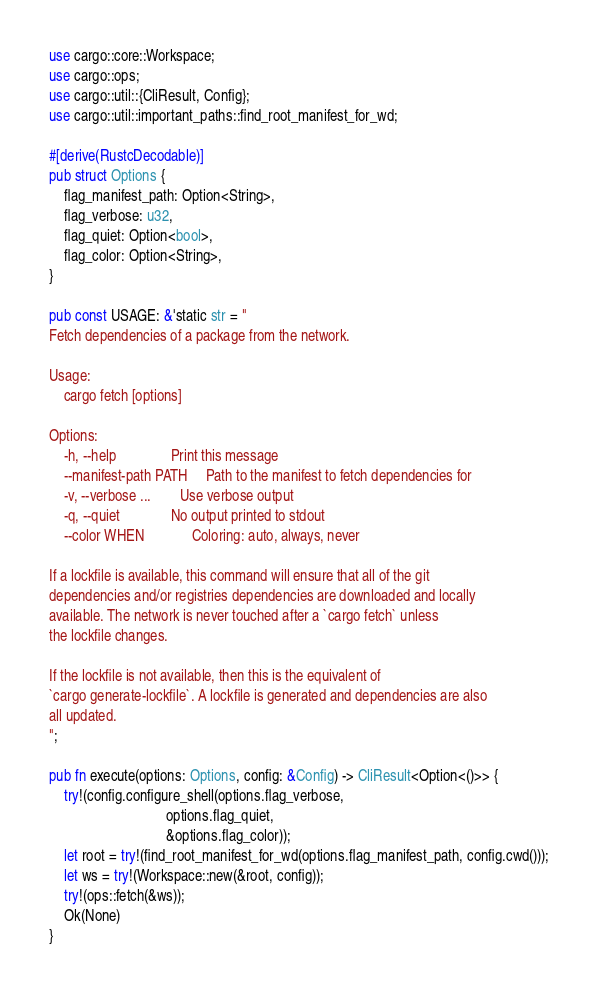<code> <loc_0><loc_0><loc_500><loc_500><_Rust_>use cargo::core::Workspace;
use cargo::ops;
use cargo::util::{CliResult, Config};
use cargo::util::important_paths::find_root_manifest_for_wd;

#[derive(RustcDecodable)]
pub struct Options {
    flag_manifest_path: Option<String>,
    flag_verbose: u32,
    flag_quiet: Option<bool>,
    flag_color: Option<String>,
}

pub const USAGE: &'static str = "
Fetch dependencies of a package from the network.

Usage:
    cargo fetch [options]

Options:
    -h, --help               Print this message
    --manifest-path PATH     Path to the manifest to fetch dependencies for
    -v, --verbose ...        Use verbose output
    -q, --quiet              No output printed to stdout
    --color WHEN             Coloring: auto, always, never

If a lockfile is available, this command will ensure that all of the git
dependencies and/or registries dependencies are downloaded and locally
available. The network is never touched after a `cargo fetch` unless
the lockfile changes.

If the lockfile is not available, then this is the equivalent of
`cargo generate-lockfile`. A lockfile is generated and dependencies are also
all updated.
";

pub fn execute(options: Options, config: &Config) -> CliResult<Option<()>> {
    try!(config.configure_shell(options.flag_verbose,
                                options.flag_quiet,
                                &options.flag_color));
    let root = try!(find_root_manifest_for_wd(options.flag_manifest_path, config.cwd()));
    let ws = try!(Workspace::new(&root, config));
    try!(ops::fetch(&ws));
    Ok(None)
}

</code> 